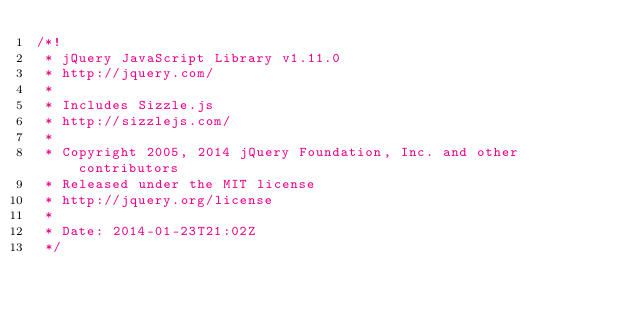Convert code to text. <code><loc_0><loc_0><loc_500><loc_500><_JavaScript_>/*!
 * jQuery JavaScript Library v1.11.0
 * http://jquery.com/
 *
 * Includes Sizzle.js
 * http://sizzlejs.com/
 *
 * Copyright 2005, 2014 jQuery Foundation, Inc. and other contributors
 * Released under the MIT license
 * http://jquery.org/license
 *
 * Date: 2014-01-23T21:02Z
 */</code> 